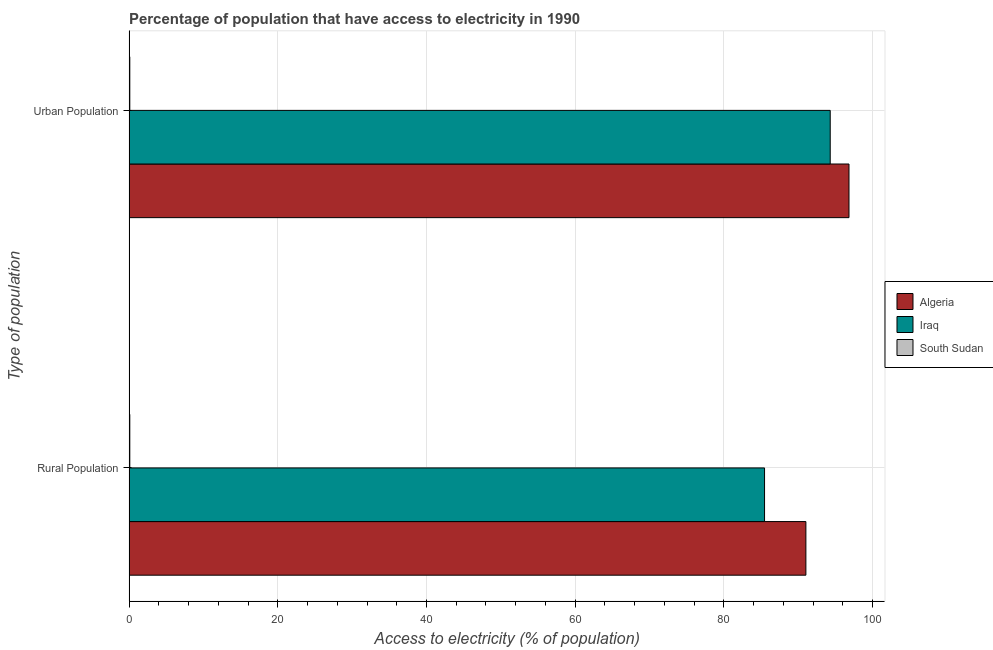How many different coloured bars are there?
Provide a short and direct response. 3. How many groups of bars are there?
Your response must be concise. 2. Are the number of bars per tick equal to the number of legend labels?
Ensure brevity in your answer.  Yes. Are the number of bars on each tick of the Y-axis equal?
Your answer should be compact. Yes. How many bars are there on the 1st tick from the top?
Offer a terse response. 3. How many bars are there on the 2nd tick from the bottom?
Offer a very short reply. 3. What is the label of the 1st group of bars from the top?
Ensure brevity in your answer.  Urban Population. Across all countries, what is the maximum percentage of rural population having access to electricity?
Offer a terse response. 91.02. Across all countries, what is the minimum percentage of urban population having access to electricity?
Give a very brief answer. 0.1. In which country was the percentage of urban population having access to electricity maximum?
Make the answer very short. Algeria. In which country was the percentage of rural population having access to electricity minimum?
Offer a terse response. South Sudan. What is the total percentage of urban population having access to electricity in the graph?
Offer a very short reply. 191.2. What is the difference between the percentage of urban population having access to electricity in Algeria and that in Iraq?
Give a very brief answer. 2.52. What is the difference between the percentage of rural population having access to electricity in Iraq and the percentage of urban population having access to electricity in Algeria?
Make the answer very short. -11.35. What is the average percentage of urban population having access to electricity per country?
Offer a very short reply. 63.73. What is the difference between the percentage of rural population having access to electricity and percentage of urban population having access to electricity in Algeria?
Provide a short and direct response. -5.79. In how many countries, is the percentage of rural population having access to electricity greater than 76 %?
Keep it short and to the point. 2. What is the ratio of the percentage of rural population having access to electricity in South Sudan to that in Iraq?
Make the answer very short. 0. What does the 2nd bar from the top in Urban Population represents?
Ensure brevity in your answer.  Iraq. What does the 3rd bar from the bottom in Rural Population represents?
Your response must be concise. South Sudan. How many bars are there?
Offer a terse response. 6. How many countries are there in the graph?
Keep it short and to the point. 3. What is the difference between two consecutive major ticks on the X-axis?
Ensure brevity in your answer.  20. Does the graph contain any zero values?
Make the answer very short. No. What is the title of the graph?
Your response must be concise. Percentage of population that have access to electricity in 1990. Does "Sub-Saharan Africa (developing only)" appear as one of the legend labels in the graph?
Your answer should be compact. No. What is the label or title of the X-axis?
Your answer should be compact. Access to electricity (% of population). What is the label or title of the Y-axis?
Offer a very short reply. Type of population. What is the Access to electricity (% of population) in Algeria in Rural Population?
Offer a very short reply. 91.02. What is the Access to electricity (% of population) in Iraq in Rural Population?
Offer a very short reply. 85.46. What is the Access to electricity (% of population) of South Sudan in Rural Population?
Ensure brevity in your answer.  0.1. What is the Access to electricity (% of population) of Algeria in Urban Population?
Ensure brevity in your answer.  96.81. What is the Access to electricity (% of population) in Iraq in Urban Population?
Ensure brevity in your answer.  94.29. What is the Access to electricity (% of population) of South Sudan in Urban Population?
Provide a short and direct response. 0.1. Across all Type of population, what is the maximum Access to electricity (% of population) of Algeria?
Provide a short and direct response. 96.81. Across all Type of population, what is the maximum Access to electricity (% of population) of Iraq?
Keep it short and to the point. 94.29. Across all Type of population, what is the minimum Access to electricity (% of population) in Algeria?
Provide a short and direct response. 91.02. Across all Type of population, what is the minimum Access to electricity (% of population) of Iraq?
Your answer should be very brief. 85.46. Across all Type of population, what is the minimum Access to electricity (% of population) of South Sudan?
Give a very brief answer. 0.1. What is the total Access to electricity (% of population) in Algeria in the graph?
Make the answer very short. 187.83. What is the total Access to electricity (% of population) in Iraq in the graph?
Give a very brief answer. 179.75. What is the total Access to electricity (% of population) of South Sudan in the graph?
Provide a short and direct response. 0.2. What is the difference between the Access to electricity (% of population) of Algeria in Rural Population and that in Urban Population?
Provide a succinct answer. -5.79. What is the difference between the Access to electricity (% of population) in Iraq in Rural Population and that in Urban Population?
Keep it short and to the point. -8.83. What is the difference between the Access to electricity (% of population) of South Sudan in Rural Population and that in Urban Population?
Give a very brief answer. 0. What is the difference between the Access to electricity (% of population) of Algeria in Rural Population and the Access to electricity (% of population) of Iraq in Urban Population?
Give a very brief answer. -3.27. What is the difference between the Access to electricity (% of population) of Algeria in Rural Population and the Access to electricity (% of population) of South Sudan in Urban Population?
Provide a succinct answer. 90.92. What is the difference between the Access to electricity (% of population) of Iraq in Rural Population and the Access to electricity (% of population) of South Sudan in Urban Population?
Your answer should be very brief. 85.36. What is the average Access to electricity (% of population) of Algeria per Type of population?
Provide a short and direct response. 93.92. What is the average Access to electricity (% of population) in Iraq per Type of population?
Offer a terse response. 89.88. What is the difference between the Access to electricity (% of population) in Algeria and Access to electricity (% of population) in Iraq in Rural Population?
Your answer should be compact. 5.56. What is the difference between the Access to electricity (% of population) in Algeria and Access to electricity (% of population) in South Sudan in Rural Population?
Keep it short and to the point. 90.92. What is the difference between the Access to electricity (% of population) of Iraq and Access to electricity (% of population) of South Sudan in Rural Population?
Your response must be concise. 85.36. What is the difference between the Access to electricity (% of population) of Algeria and Access to electricity (% of population) of Iraq in Urban Population?
Offer a terse response. 2.52. What is the difference between the Access to electricity (% of population) in Algeria and Access to electricity (% of population) in South Sudan in Urban Population?
Offer a terse response. 96.71. What is the difference between the Access to electricity (% of population) of Iraq and Access to electricity (% of population) of South Sudan in Urban Population?
Your answer should be very brief. 94.19. What is the ratio of the Access to electricity (% of population) of Algeria in Rural Population to that in Urban Population?
Ensure brevity in your answer.  0.94. What is the ratio of the Access to electricity (% of population) of Iraq in Rural Population to that in Urban Population?
Provide a succinct answer. 0.91. What is the difference between the highest and the second highest Access to electricity (% of population) of Algeria?
Offer a terse response. 5.79. What is the difference between the highest and the second highest Access to electricity (% of population) in Iraq?
Your answer should be very brief. 8.83. What is the difference between the highest and the lowest Access to electricity (% of population) of Algeria?
Give a very brief answer. 5.79. What is the difference between the highest and the lowest Access to electricity (% of population) of Iraq?
Give a very brief answer. 8.83. What is the difference between the highest and the lowest Access to electricity (% of population) in South Sudan?
Provide a succinct answer. 0. 